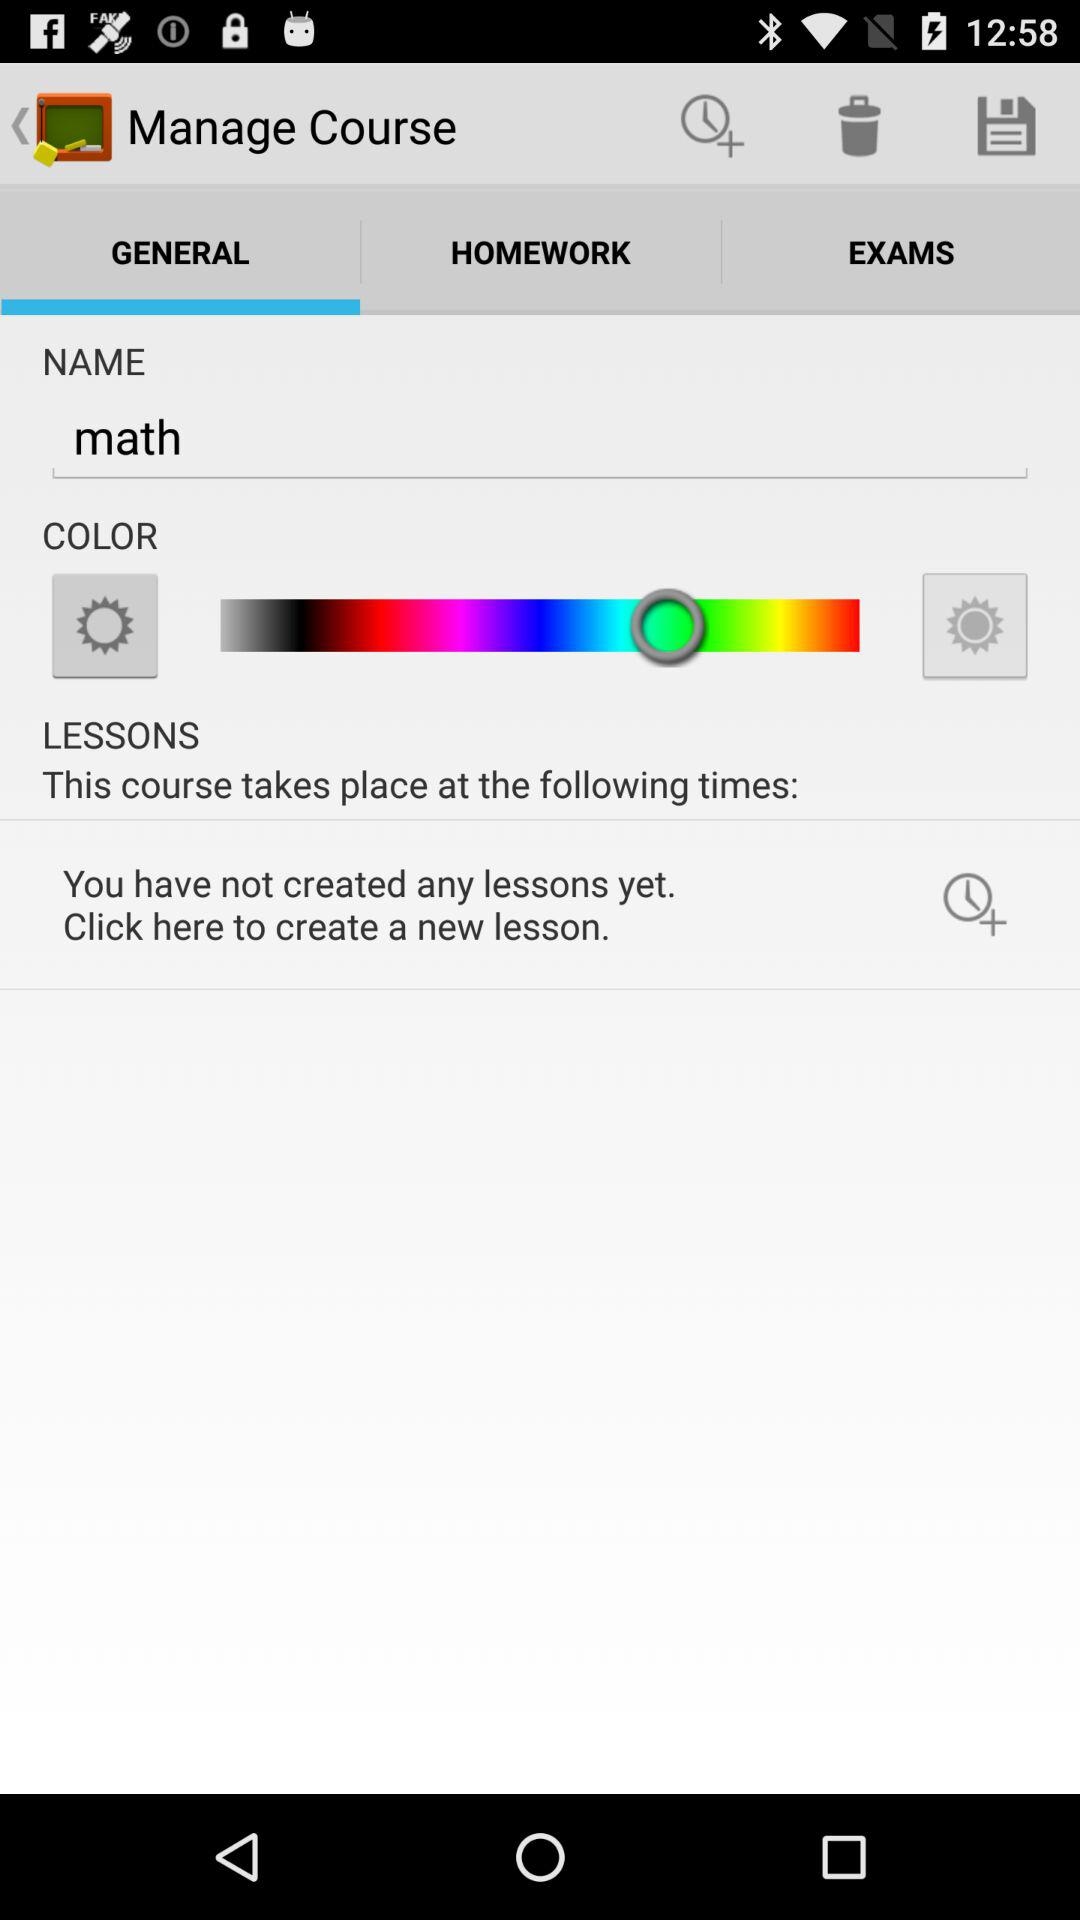Which tab has been selected? The selected tab is "GENERAL". 